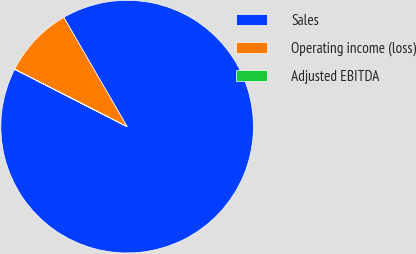Convert chart to OTSL. <chart><loc_0><loc_0><loc_500><loc_500><pie_chart><fcel>Sales<fcel>Operating income (loss)<fcel>Adjusted EBITDA<nl><fcel>90.85%<fcel>9.12%<fcel>0.03%<nl></chart> 